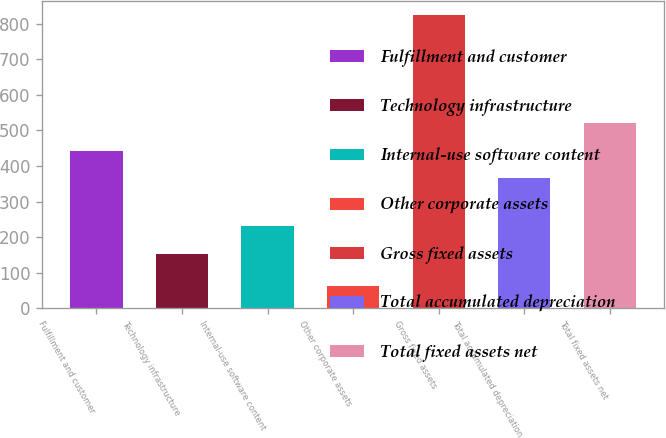Convert chart. <chart><loc_0><loc_0><loc_500><loc_500><bar_chart><fcel>Fulfillment and customer<fcel>Technology infrastructure<fcel>Internal-use software content<fcel>Other corporate assets<fcel>Gross fixed assets<fcel>Total accumulated depreciation<fcel>Total fixed assets net<nl><fcel>443.2<fcel>153<fcel>230<fcel>62<fcel>824<fcel>367<fcel>519.4<nl></chart> 